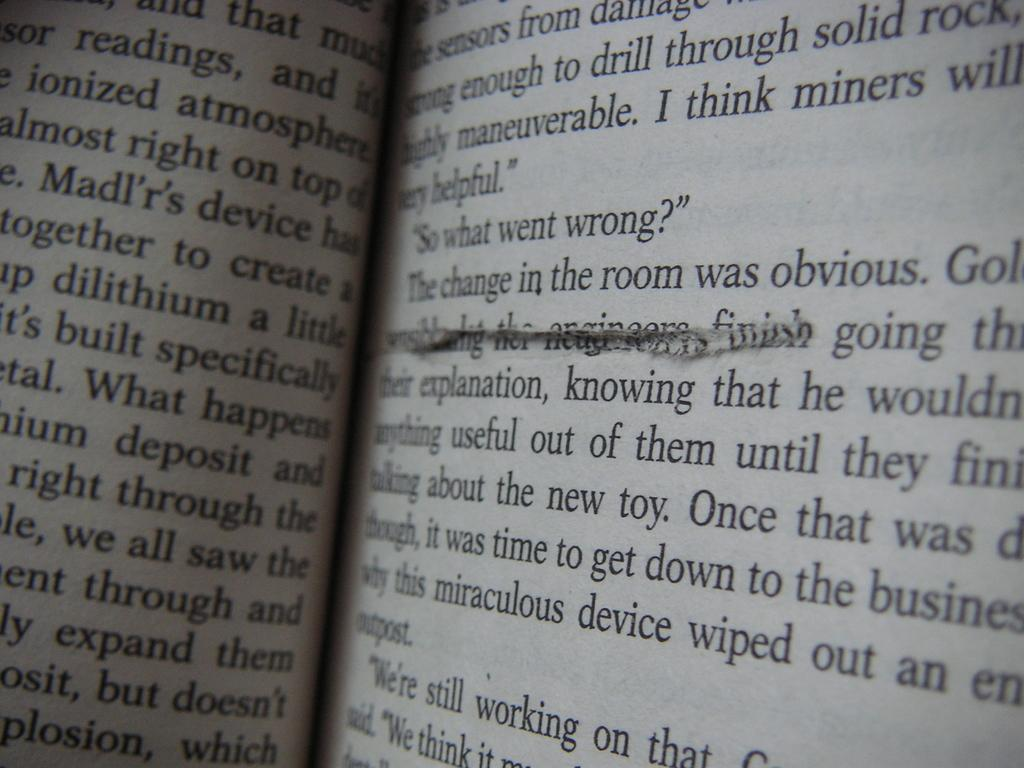Provide a one-sentence caption for the provided image. A book page is torn or cut below the words "in the room was obvious". 